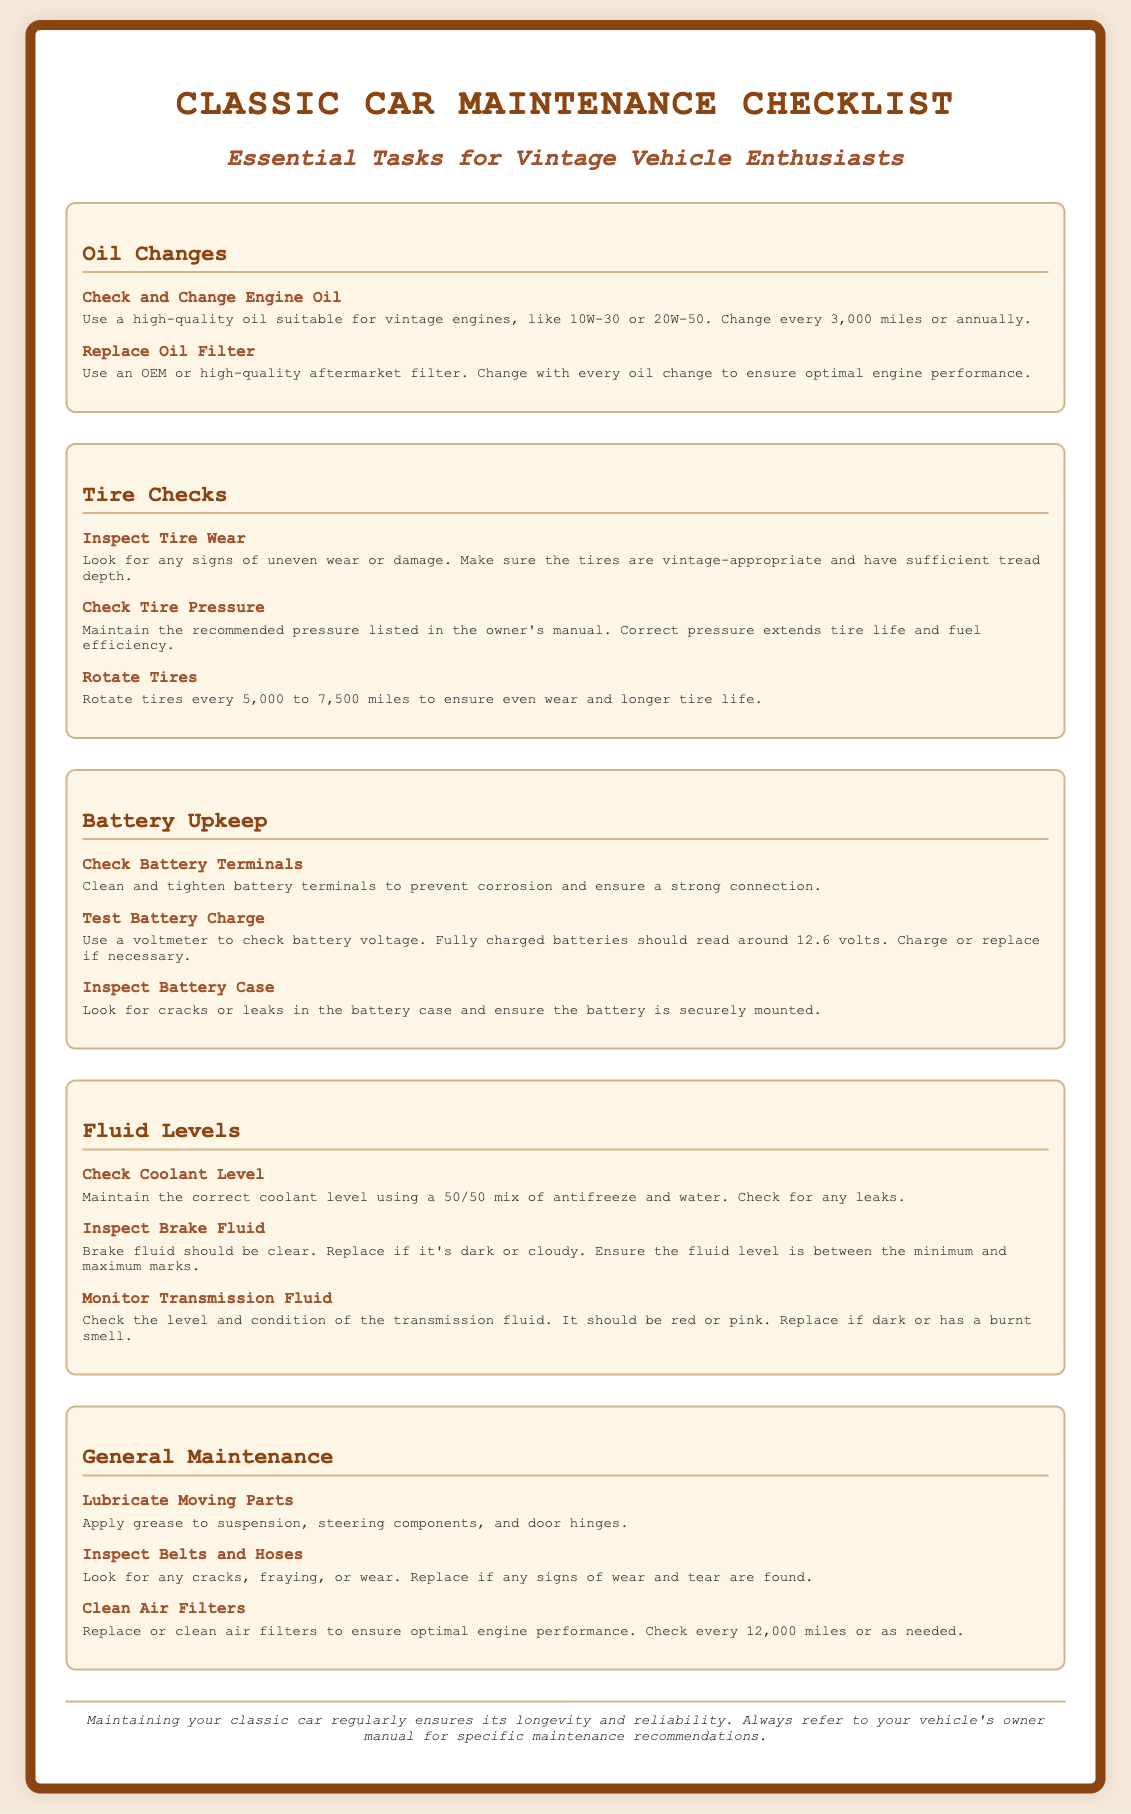What is the main title of the document? The main title is presented at the top of the document and highlights the focus of the content.
Answer: Classic Car Maintenance Checklist How often should you change the engine oil? The document states a specific interval for oil changes to ensure proper engine function.
Answer: Every 3,000 miles or annually What is the recommended tire pressure maintenance? The document mentions maintaining tire pressure for efficiency and safety.
Answer: Recommended pressure in owner's manual What should you inspect regarding brake fluid? The document specifies the appearance and level that should be monitored for brake fluid.
Answer: Clear; between minimum and maximum marks What action should be taken if the transmission fluid is dark? The document provides guidance on the condition of the transmission fluid and necessary actions.
Answer: Replace if dark or has a burnt smell How frequently should you rotate tires? The document outlines a specific mileage interval for tire rotation to promote even wear.
Answer: Every 5,000 to 7,500 miles What should you do to battery terminals? The document suggests a specific action necessary to maintain battery performance.
Answer: Clean and tighten What mixture should be used for coolant maintenance? The document provides a specific ratio for the coolant to maintain proper vehicle temperature.
Answer: 50/50 mix of antifreeze and water What is the purpose of checking the air filters? The document highlights the importance of air filters for engine performance.
Answer: Ensure optimal engine performance 